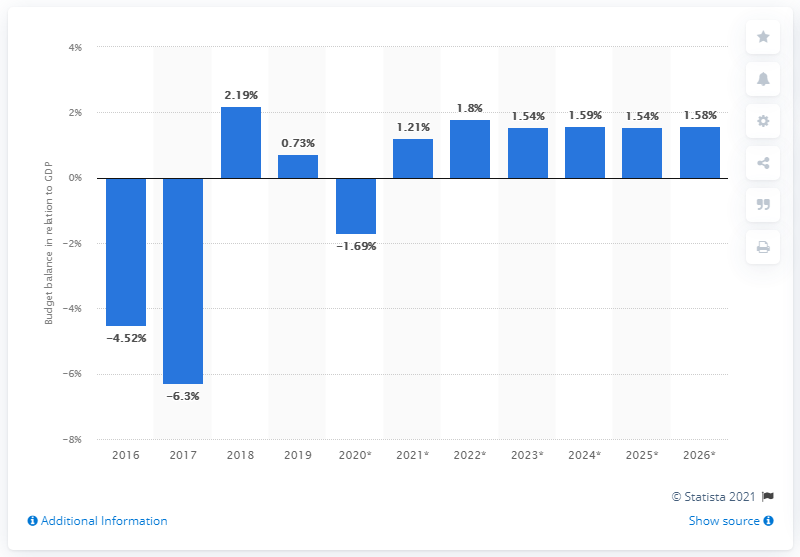Draw attention to some important aspects in this diagram. In 2019, Angola's budget surplus made up approximately 0.73% of its total GDP. 